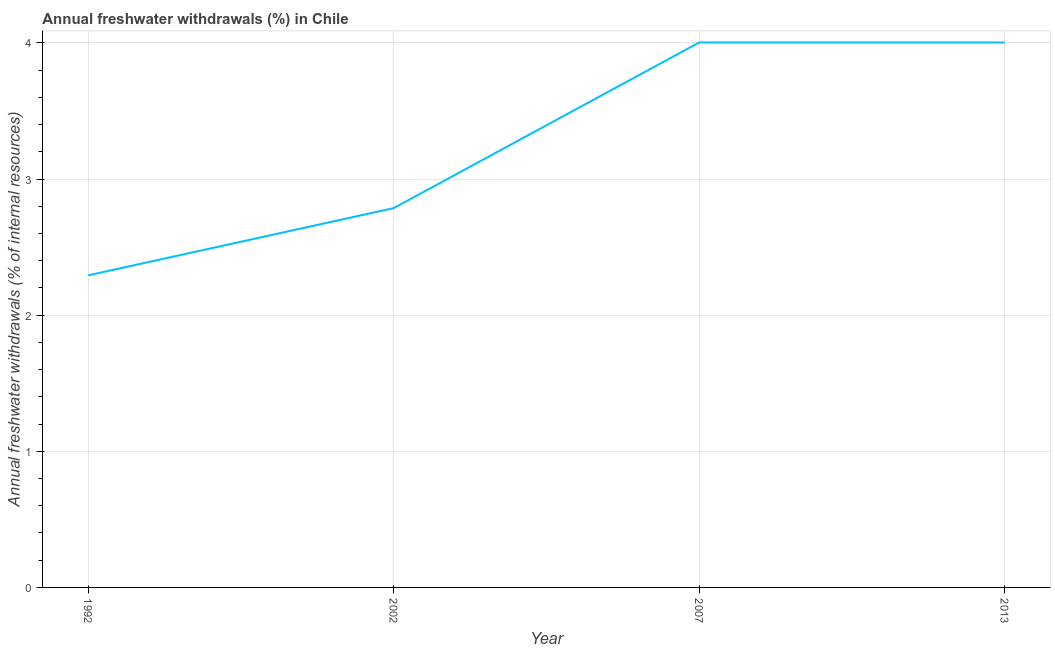What is the annual freshwater withdrawals in 2007?
Keep it short and to the point. 4. Across all years, what is the maximum annual freshwater withdrawals?
Offer a very short reply. 4. Across all years, what is the minimum annual freshwater withdrawals?
Your answer should be very brief. 2.29. In which year was the annual freshwater withdrawals maximum?
Your response must be concise. 2007. In which year was the annual freshwater withdrawals minimum?
Make the answer very short. 1992. What is the sum of the annual freshwater withdrawals?
Your answer should be very brief. 13.09. What is the difference between the annual freshwater withdrawals in 1992 and 2007?
Give a very brief answer. -1.71. What is the average annual freshwater withdrawals per year?
Provide a succinct answer. 3.27. What is the median annual freshwater withdrawals?
Your response must be concise. 3.39. In how many years, is the annual freshwater withdrawals greater than 2.8 %?
Offer a very short reply. 2. Do a majority of the years between 2002 and 2007 (inclusive) have annual freshwater withdrawals greater than 0.8 %?
Provide a short and direct response. Yes. What is the ratio of the annual freshwater withdrawals in 2002 to that in 2013?
Make the answer very short. 0.7. Is the annual freshwater withdrawals in 2002 less than that in 2007?
Make the answer very short. Yes. Is the difference between the annual freshwater withdrawals in 1992 and 2007 greater than the difference between any two years?
Provide a succinct answer. Yes. Is the sum of the annual freshwater withdrawals in 1992 and 2002 greater than the maximum annual freshwater withdrawals across all years?
Provide a short and direct response. Yes. What is the difference between the highest and the lowest annual freshwater withdrawals?
Ensure brevity in your answer.  1.71. How many lines are there?
Ensure brevity in your answer.  1. How many years are there in the graph?
Your answer should be very brief. 4. What is the difference between two consecutive major ticks on the Y-axis?
Give a very brief answer. 1. Does the graph contain any zero values?
Offer a very short reply. No. Does the graph contain grids?
Your answer should be very brief. Yes. What is the title of the graph?
Keep it short and to the point. Annual freshwater withdrawals (%) in Chile. What is the label or title of the Y-axis?
Offer a very short reply. Annual freshwater withdrawals (% of internal resources). What is the Annual freshwater withdrawals (% of internal resources) of 1992?
Your answer should be compact. 2.29. What is the Annual freshwater withdrawals (% of internal resources) of 2002?
Provide a succinct answer. 2.79. What is the Annual freshwater withdrawals (% of internal resources) in 2007?
Your response must be concise. 4. What is the Annual freshwater withdrawals (% of internal resources) in 2013?
Keep it short and to the point. 4. What is the difference between the Annual freshwater withdrawals (% of internal resources) in 1992 and 2002?
Your answer should be compact. -0.49. What is the difference between the Annual freshwater withdrawals (% of internal resources) in 1992 and 2007?
Your answer should be very brief. -1.71. What is the difference between the Annual freshwater withdrawals (% of internal resources) in 1992 and 2013?
Provide a succinct answer. -1.71. What is the difference between the Annual freshwater withdrawals (% of internal resources) in 2002 and 2007?
Provide a succinct answer. -1.22. What is the difference between the Annual freshwater withdrawals (% of internal resources) in 2002 and 2013?
Offer a terse response. -1.22. What is the difference between the Annual freshwater withdrawals (% of internal resources) in 2007 and 2013?
Your answer should be compact. 0. What is the ratio of the Annual freshwater withdrawals (% of internal resources) in 1992 to that in 2002?
Keep it short and to the point. 0.82. What is the ratio of the Annual freshwater withdrawals (% of internal resources) in 1992 to that in 2007?
Ensure brevity in your answer.  0.57. What is the ratio of the Annual freshwater withdrawals (% of internal resources) in 1992 to that in 2013?
Your answer should be very brief. 0.57. What is the ratio of the Annual freshwater withdrawals (% of internal resources) in 2002 to that in 2007?
Provide a short and direct response. 0.7. What is the ratio of the Annual freshwater withdrawals (% of internal resources) in 2002 to that in 2013?
Your answer should be compact. 0.7. 